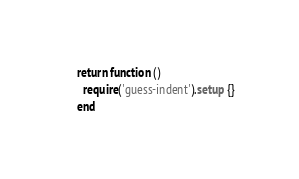Convert code to text. <code><loc_0><loc_0><loc_500><loc_500><_Lua_>return function ()
  require('guess-indent').setup {}
end
</code> 